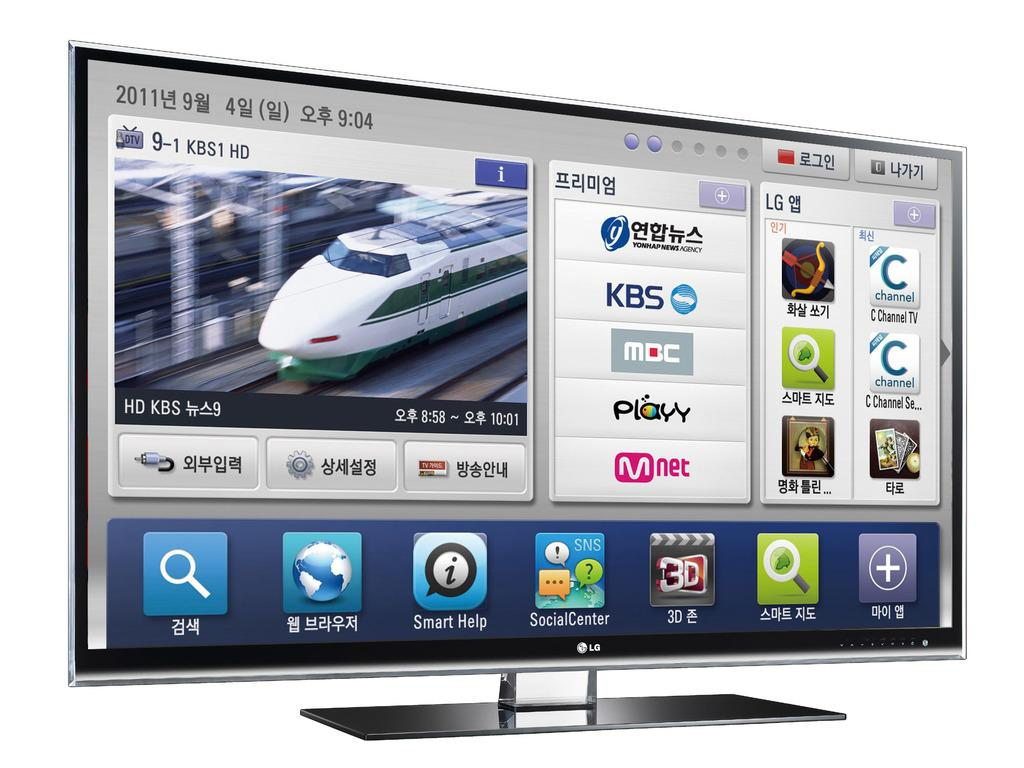What brand of TV is visible in the image? There is an LG TV in the image. What is the TV displaying? There is a picture displayed on the TV. What type of snail can be seen crawling on the TV in the image? There is no snail present on the TV or in the image. What type of plough is being used to dig near the TV in the image? There is no plough or digging activity present in the image. 